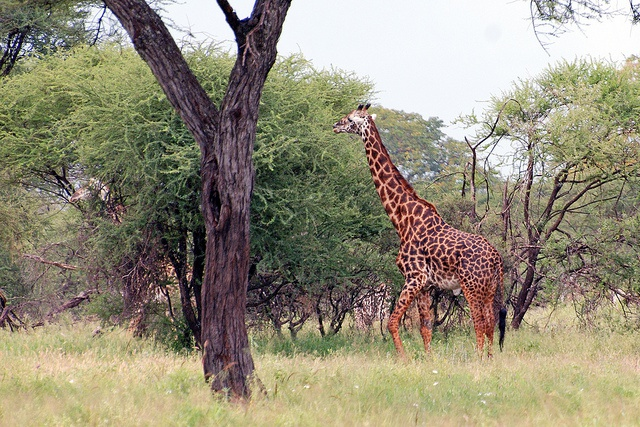Describe the objects in this image and their specific colors. I can see a giraffe in olive, brown, maroon, tan, and black tones in this image. 